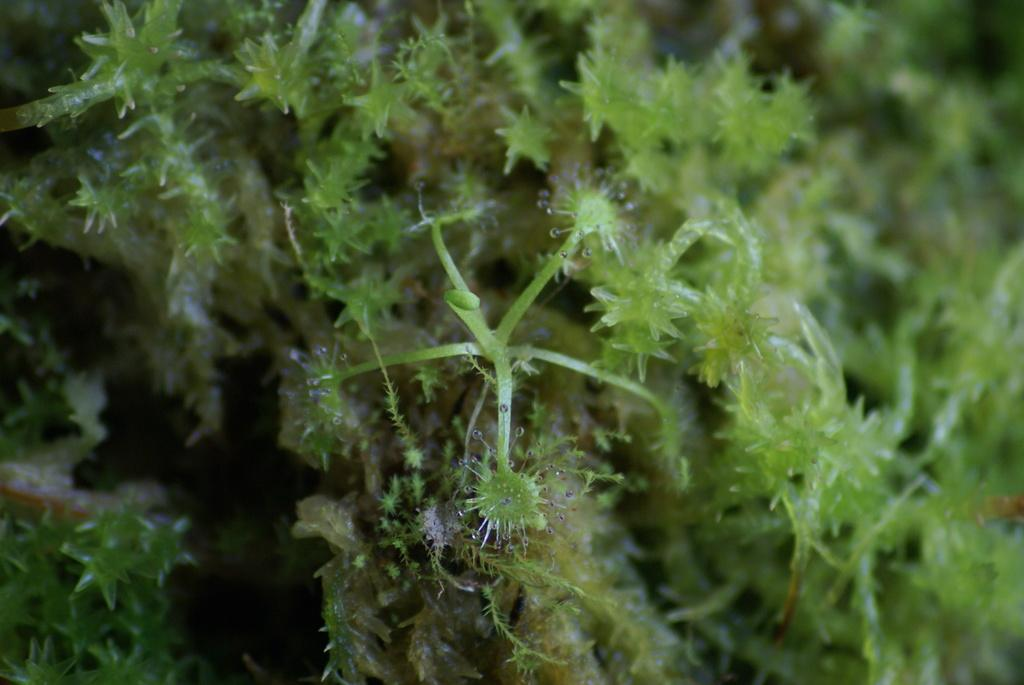What type of plants are present in the image? There are liverworts in the image. Can you describe the appearance of the liverworts? Liverworts are small, non-vascular plants that often have a flattened, leaf-like structure. Are there any other plants or organisms visible in the image? The provided facts only mention liverworts, so there is no information about other plants or organisms in the image. What type of needle is being used to sew the animal in the image? There is no needle or animal present in the image; it only contains liverworts. Can you tell me how many bulbs are visible in the image? There are no bulbs present in the image; it only contains liverworts. 